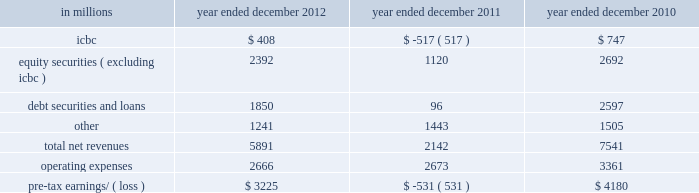Management 2019s discussion and analysis net revenues in equities were $ 8.26 billion for 2011 , 2% ( 2 % ) higher than 2010 .
During 2011 , average volatility levels increased and equity prices in europe and asia declined significantly , particularly during the third quarter .
The increase in net revenues reflected higher commissions and fees , primarily due to higher market volumes , particularly during the third quarter of 2011 .
In addition , net revenues in securities services increased compared with 2010 , reflecting the impact of higher average customer balances .
Equities client execution net revenues were lower than 2010 , primarily reflecting significantly lower net revenues in shares .
The net gain attributable to the impact of changes in our own credit spreads on borrowings for which the fair value option was elected was $ 596 million ( $ 399 million and $ 197 million related to fixed income , currency and commodities client execution and equities client execution , respectively ) for 2011 , compared with a net gain of $ 198 million ( $ 188 million and $ 10 million related to fixed income , currency and commodities client execution and equities client execution , respectively ) for 2010 .
Institutional client services operated in an environment generally characterized by increased concerns regarding the weakened state of global economies , including heightened european sovereign debt risk , and its impact on the european banking system and global financial institutions .
These conditions also impacted expectations for economic prospects in the united states and were reflected in equity and debt markets more broadly .
In addition , the downgrade in credit ratings of the u.s .
Government and federal agencies and many financial institutions during the second half of 2011 contributed to further uncertainty in the markets .
These concerns , as well as other broad market concerns , such as uncertainty over financial regulatory reform , continued to have a negative impact on our net revenues during 2011 .
Operating expenses were $ 12.84 billion for 2011 , 14% ( 14 % ) lower than 2010 , due to decreased compensation and benefits expenses , primarily resulting from lower net revenues , lower net provisions for litigation and regulatory proceedings ( 2010 included $ 550 million related to a settlement with the sec ) , the impact of the u.k .
Bank payroll tax during 2010 , as well as an impairment of our nyse dmm rights of $ 305 million during 2010 .
These decreases were partially offset by higher brokerage , clearing , exchange and distribution fees , principally reflecting higher transaction volumes in equities .
Pre-tax earnings were $ 4.44 billion in 2011 , 35% ( 35 % ) lower than 2010 .
Investing & lending investing & lending includes our investing activities and the origination of loans to provide financing to clients .
These investments and loans are typically longer-term in nature .
We make investments , directly and indirectly through funds that we manage , in debt securities and loans , public and private equity securities , real estate , consolidated investment entities and power generation facilities .
The table below presents the operating results of our investing & lending segment. .
2012 versus 2011 .
Net revenues in investing & lending were $ 5.89 billion and $ 2.14 billion for 2012 and 2011 , respectively .
During 2012 , investing & lending net revenues were positively impacted by tighter credit spreads and an increase in global equity prices .
Results for 2012 included a gain of $ 408 million from our investment in the ordinary shares of icbc , net gains of $ 2.39 billion from other investments in equities , primarily in private equities , net gains and net interest income of $ 1.85 billion from debt securities and loans , and other net revenues of $ 1.24 billion , principally related to our consolidated investment entities .
If equity markets decline or credit spreads widen , net revenues in investing & lending would likely be negatively impacted .
Operating expenses were $ 2.67 billion for 2012 , essentially unchanged compared with 2011 .
Pre-tax earnings were $ 3.23 billion in 2012 , compared with a pre-tax loss of $ 531 million in 2011 .
Goldman sachs 2012 annual report 55 .
What percentage of total net revenues in 2011 where due to equity securities ( excluding icbc ) revenues? 
Computations: (1120 / 2142)
Answer: 0.52288. Management 2019s discussion and analysis net revenues in equities were $ 8.26 billion for 2011 , 2% ( 2 % ) higher than 2010 .
During 2011 , average volatility levels increased and equity prices in europe and asia declined significantly , particularly during the third quarter .
The increase in net revenues reflected higher commissions and fees , primarily due to higher market volumes , particularly during the third quarter of 2011 .
In addition , net revenues in securities services increased compared with 2010 , reflecting the impact of higher average customer balances .
Equities client execution net revenues were lower than 2010 , primarily reflecting significantly lower net revenues in shares .
The net gain attributable to the impact of changes in our own credit spreads on borrowings for which the fair value option was elected was $ 596 million ( $ 399 million and $ 197 million related to fixed income , currency and commodities client execution and equities client execution , respectively ) for 2011 , compared with a net gain of $ 198 million ( $ 188 million and $ 10 million related to fixed income , currency and commodities client execution and equities client execution , respectively ) for 2010 .
Institutional client services operated in an environment generally characterized by increased concerns regarding the weakened state of global economies , including heightened european sovereign debt risk , and its impact on the european banking system and global financial institutions .
These conditions also impacted expectations for economic prospects in the united states and were reflected in equity and debt markets more broadly .
In addition , the downgrade in credit ratings of the u.s .
Government and federal agencies and many financial institutions during the second half of 2011 contributed to further uncertainty in the markets .
These concerns , as well as other broad market concerns , such as uncertainty over financial regulatory reform , continued to have a negative impact on our net revenues during 2011 .
Operating expenses were $ 12.84 billion for 2011 , 14% ( 14 % ) lower than 2010 , due to decreased compensation and benefits expenses , primarily resulting from lower net revenues , lower net provisions for litigation and regulatory proceedings ( 2010 included $ 550 million related to a settlement with the sec ) , the impact of the u.k .
Bank payroll tax during 2010 , as well as an impairment of our nyse dmm rights of $ 305 million during 2010 .
These decreases were partially offset by higher brokerage , clearing , exchange and distribution fees , principally reflecting higher transaction volumes in equities .
Pre-tax earnings were $ 4.44 billion in 2011 , 35% ( 35 % ) lower than 2010 .
Investing & lending investing & lending includes our investing activities and the origination of loans to provide financing to clients .
These investments and loans are typically longer-term in nature .
We make investments , directly and indirectly through funds that we manage , in debt securities and loans , public and private equity securities , real estate , consolidated investment entities and power generation facilities .
The table below presents the operating results of our investing & lending segment. .
2012 versus 2011 .
Net revenues in investing & lending were $ 5.89 billion and $ 2.14 billion for 2012 and 2011 , respectively .
During 2012 , investing & lending net revenues were positively impacted by tighter credit spreads and an increase in global equity prices .
Results for 2012 included a gain of $ 408 million from our investment in the ordinary shares of icbc , net gains of $ 2.39 billion from other investments in equities , primarily in private equities , net gains and net interest income of $ 1.85 billion from debt securities and loans , and other net revenues of $ 1.24 billion , principally related to our consolidated investment entities .
If equity markets decline or credit spreads widen , net revenues in investing & lending would likely be negatively impacted .
Operating expenses were $ 2.67 billion for 2012 , essentially unchanged compared with 2011 .
Pre-tax earnings were $ 3.23 billion in 2012 , compared with a pre-tax loss of $ 531 million in 2011 .
Goldman sachs 2012 annual report 55 .
What was the difference in net revenues in investing & lending in billions between 2012 and 2011? 
Computations: (5.89 - 2.14)
Answer: 3.75. 